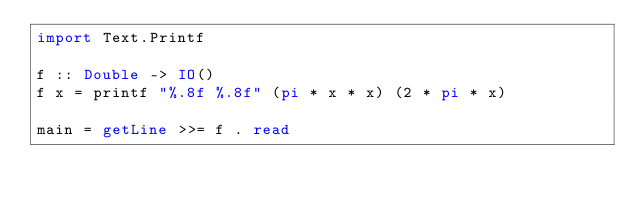<code> <loc_0><loc_0><loc_500><loc_500><_Haskell_>import Text.Printf

f :: Double -> IO()
f x = printf "%.8f %.8f" (pi * x * x) (2 * pi * x)

main = getLine >>= f . read
</code> 